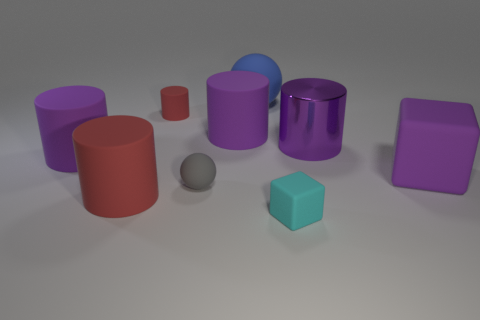Add 1 large blue metal cylinders. How many objects exist? 10 Subtract all small red matte cylinders. How many cylinders are left? 4 Subtract all gray balls. How many balls are left? 1 Subtract 0 blue cylinders. How many objects are left? 9 Subtract all spheres. How many objects are left? 7 Subtract 1 balls. How many balls are left? 1 Subtract all red cubes. Subtract all yellow cylinders. How many cubes are left? 2 Subtract all cyan cylinders. How many purple balls are left? 0 Subtract all red cylinders. Subtract all tiny cyan blocks. How many objects are left? 6 Add 2 large red cylinders. How many large red cylinders are left? 3 